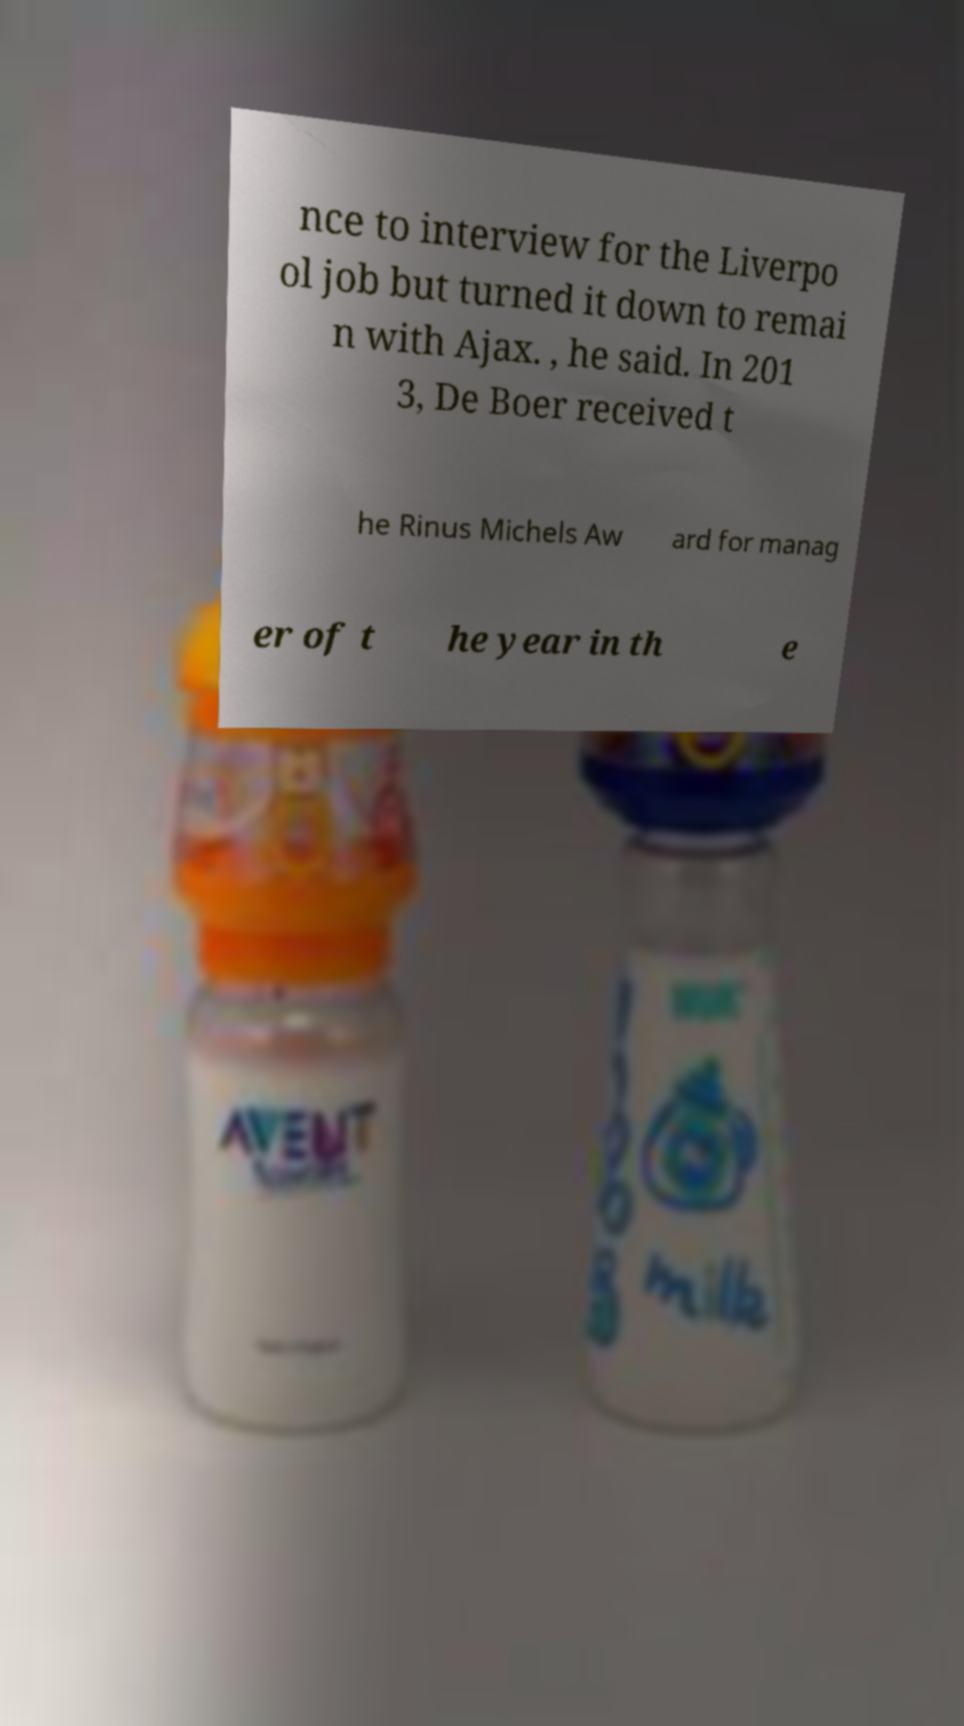Can you read and provide the text displayed in the image?This photo seems to have some interesting text. Can you extract and type it out for me? nce to interview for the Liverpo ol job but turned it down to remai n with Ajax. , he said. In 201 3, De Boer received t he Rinus Michels Aw ard for manag er of t he year in th e 